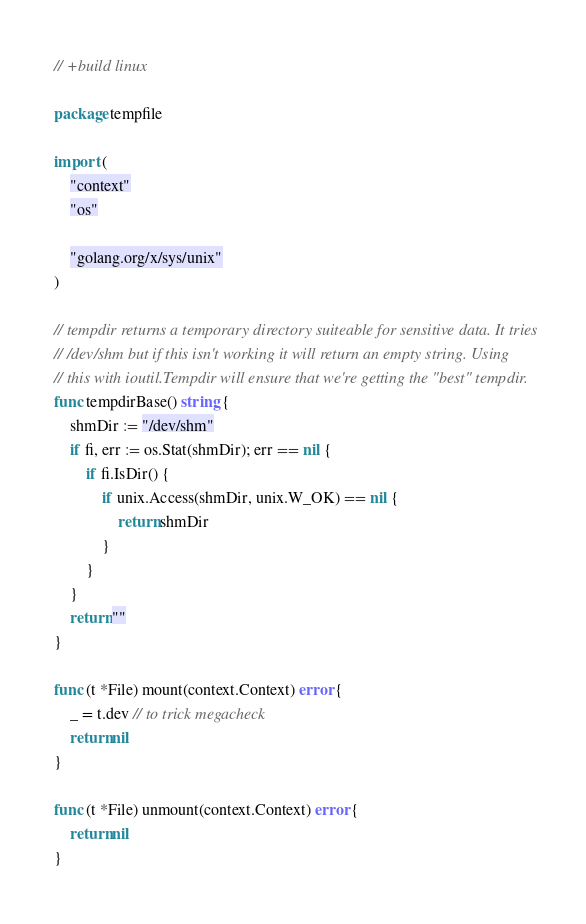<code> <loc_0><loc_0><loc_500><loc_500><_Go_>// +build linux

package tempfile

import (
	"context"
	"os"

	"golang.org/x/sys/unix"
)

// tempdir returns a temporary directory suiteable for sensitive data. It tries
// /dev/shm but if this isn't working it will return an empty string. Using
// this with ioutil.Tempdir will ensure that we're getting the "best" tempdir.
func tempdirBase() string {
	shmDir := "/dev/shm"
	if fi, err := os.Stat(shmDir); err == nil {
		if fi.IsDir() {
			if unix.Access(shmDir, unix.W_OK) == nil {
				return shmDir
			}
		}
	}
	return ""
}

func (t *File) mount(context.Context) error {
	_ = t.dev // to trick megacheck
	return nil
}

func (t *File) unmount(context.Context) error {
	return nil
}
</code> 